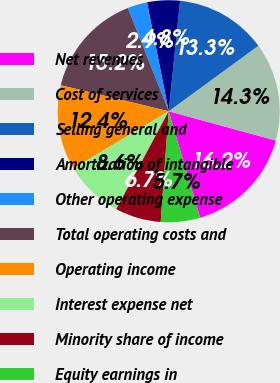Convert chart to OTSL. <chart><loc_0><loc_0><loc_500><loc_500><pie_chart><fcel>Net revenues<fcel>Cost of services<fcel>Selling general and<fcel>Amortization of intangible<fcel>Other operating expense<fcel>Total operating costs and<fcel>Operating income<fcel>Interest expense net<fcel>Minority share of income<fcel>Equity earnings in<nl><fcel>16.19%<fcel>14.29%<fcel>13.33%<fcel>4.76%<fcel>2.86%<fcel>15.24%<fcel>12.38%<fcel>8.57%<fcel>6.67%<fcel>5.71%<nl></chart> 